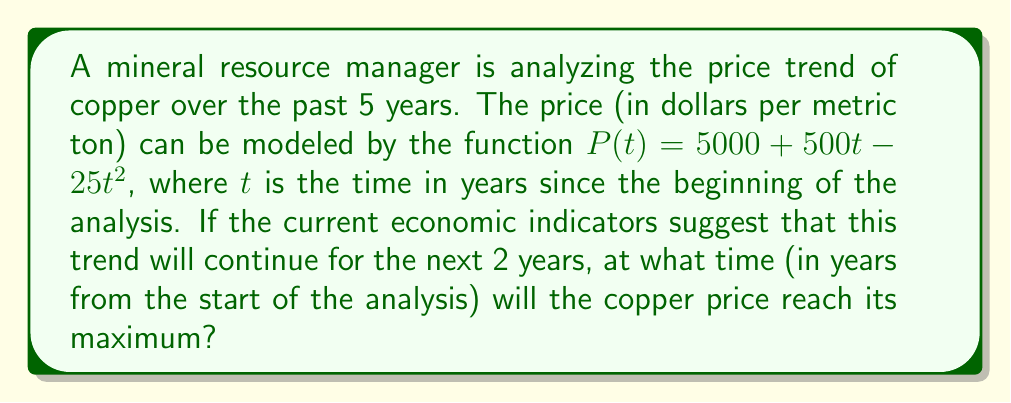Provide a solution to this math problem. To find the maximum price of copper, we need to follow these steps:

1) The function given is quadratic: $P(t) = 5000 + 500t - 25t^2$

2) For a quadratic function $f(t) = at^2 + bt + c$, the maximum or minimum occurs at $t = -\frac{b}{2a}$

3) In our case, $a = -25$, $b = 500$, and $c = 5000$

4) Substituting into the formula:

   $t = -\frac{500}{2(-25)} = -\frac{500}{-50} = 10$

5) This means the maximum price occurs 10 years from the start of the analysis

6) To verify this is a maximum (not a minimum), we can check that $a < 0$ ($-25 < 0$)

7) The question asks about the next 2 years, but the maximum occurs at 10 years. This is beyond the 7-year period (5 years of data + 2 years of prediction), but it's still the correct mathematical answer for when the price will reach its maximum according to this model.
Answer: 10 years 